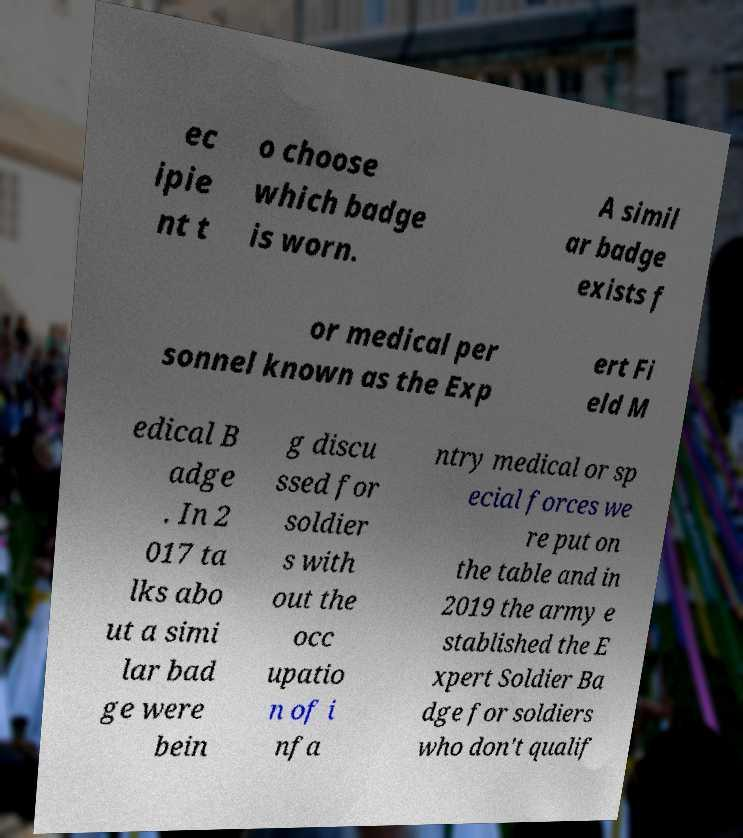Can you read and provide the text displayed in the image?This photo seems to have some interesting text. Can you extract and type it out for me? ec ipie nt t o choose which badge is worn. A simil ar badge exists f or medical per sonnel known as the Exp ert Fi eld M edical B adge . In 2 017 ta lks abo ut a simi lar bad ge were bein g discu ssed for soldier s with out the occ upatio n of i nfa ntry medical or sp ecial forces we re put on the table and in 2019 the army e stablished the E xpert Soldier Ba dge for soldiers who don't qualif 